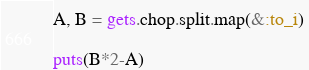Convert code to text. <code><loc_0><loc_0><loc_500><loc_500><_Ruby_>A, B = gets.chop.split.map(&:to_i)

puts(B*2-A)</code> 